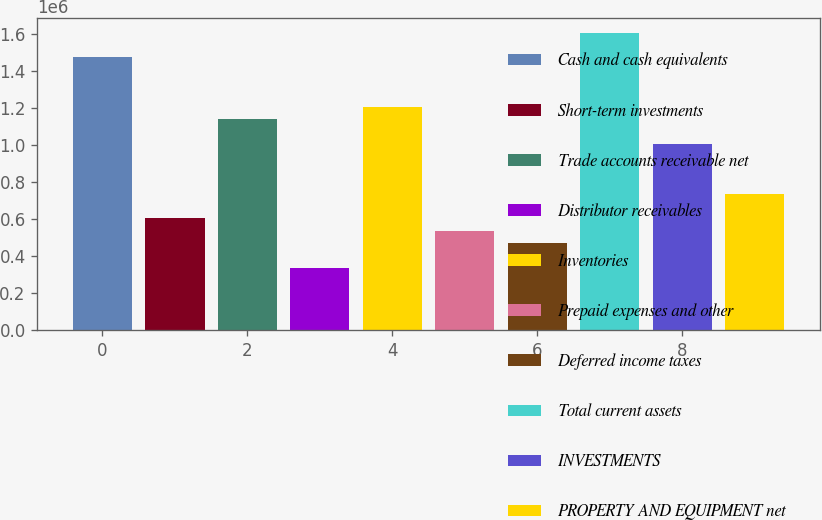Convert chart. <chart><loc_0><loc_0><loc_500><loc_500><bar_chart><fcel>Cash and cash equivalents<fcel>Short-term investments<fcel>Trade accounts receivable net<fcel>Distributor receivables<fcel>Inventories<fcel>Prepaid expenses and other<fcel>Deferred income taxes<fcel>Total current assets<fcel>INVESTMENTS<fcel>PROPERTY AND EQUIPMENT net<nl><fcel>1.47462e+06<fcel>603377<fcel>1.13953e+06<fcel>335301<fcel>1.20655e+06<fcel>536358<fcel>469339<fcel>1.60866e+06<fcel>1.00549e+06<fcel>737415<nl></chart> 